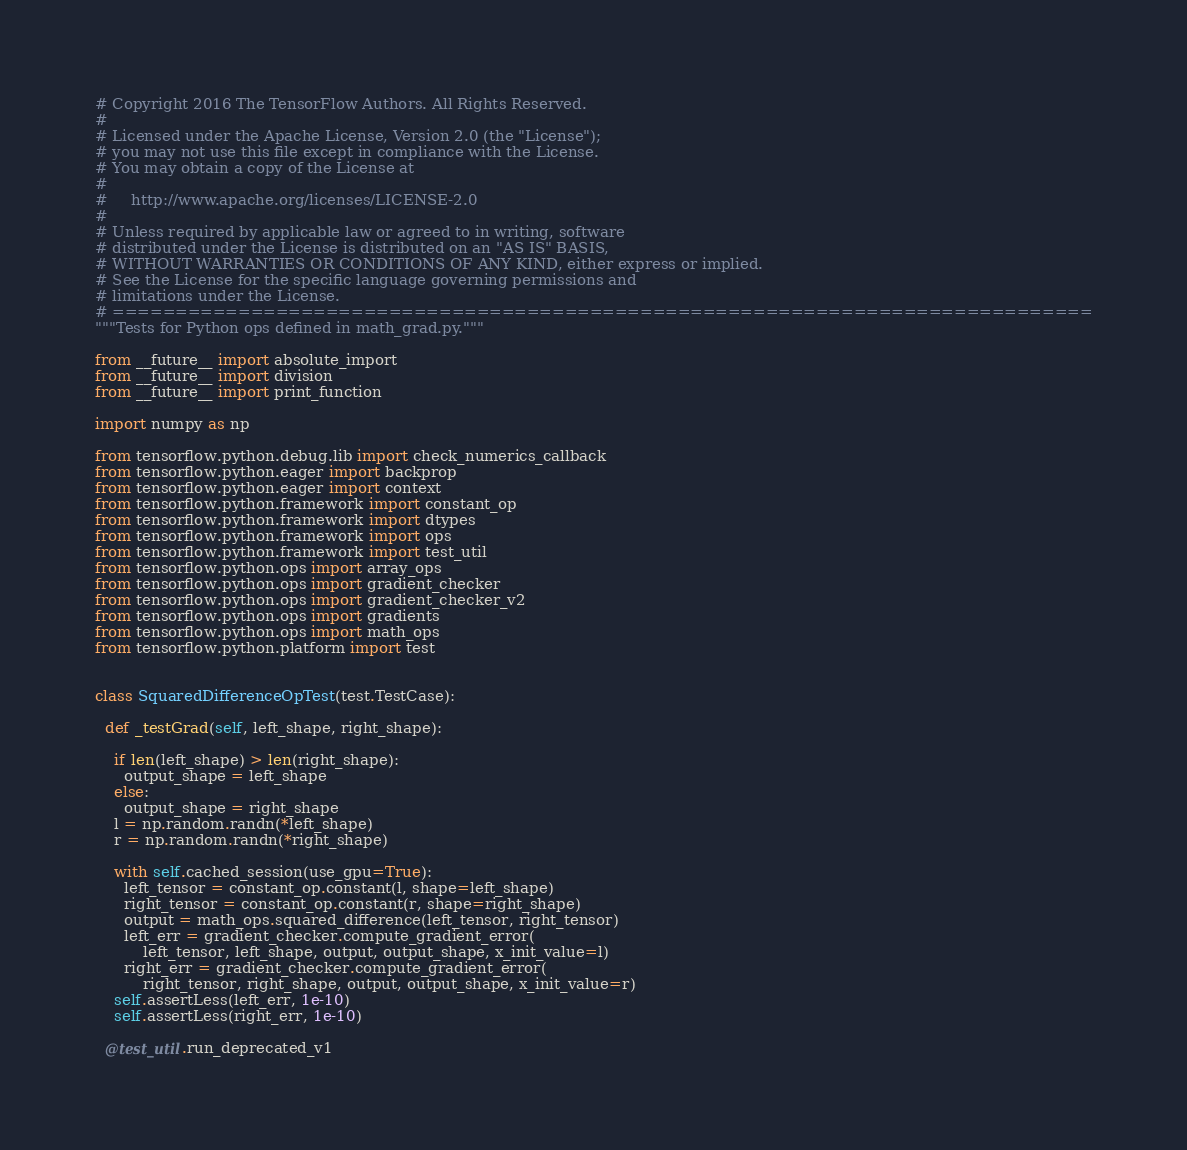Convert code to text. <code><loc_0><loc_0><loc_500><loc_500><_Python_># Copyright 2016 The TensorFlow Authors. All Rights Reserved.
#
# Licensed under the Apache License, Version 2.0 (the "License");
# you may not use this file except in compliance with the License.
# You may obtain a copy of the License at
#
#     http://www.apache.org/licenses/LICENSE-2.0
#
# Unless required by applicable law or agreed to in writing, software
# distributed under the License is distributed on an "AS IS" BASIS,
# WITHOUT WARRANTIES OR CONDITIONS OF ANY KIND, either express or implied.
# See the License for the specific language governing permissions and
# limitations under the License.
# ==============================================================================
"""Tests for Python ops defined in math_grad.py."""

from __future__ import absolute_import
from __future__ import division
from __future__ import print_function

import numpy as np

from tensorflow.python.debug.lib import check_numerics_callback
from tensorflow.python.eager import backprop
from tensorflow.python.eager import context
from tensorflow.python.framework import constant_op
from tensorflow.python.framework import dtypes
from tensorflow.python.framework import ops
from tensorflow.python.framework import test_util
from tensorflow.python.ops import array_ops
from tensorflow.python.ops import gradient_checker
from tensorflow.python.ops import gradient_checker_v2
from tensorflow.python.ops import gradients
from tensorflow.python.ops import math_ops
from tensorflow.python.platform import test


class SquaredDifferenceOpTest(test.TestCase):

  def _testGrad(self, left_shape, right_shape):

    if len(left_shape) > len(right_shape):
      output_shape = left_shape
    else:
      output_shape = right_shape
    l = np.random.randn(*left_shape)
    r = np.random.randn(*right_shape)

    with self.cached_session(use_gpu=True):
      left_tensor = constant_op.constant(l, shape=left_shape)
      right_tensor = constant_op.constant(r, shape=right_shape)
      output = math_ops.squared_difference(left_tensor, right_tensor)
      left_err = gradient_checker.compute_gradient_error(
          left_tensor, left_shape, output, output_shape, x_init_value=l)
      right_err = gradient_checker.compute_gradient_error(
          right_tensor, right_shape, output, output_shape, x_init_value=r)
    self.assertLess(left_err, 1e-10)
    self.assertLess(right_err, 1e-10)

  @test_util.run_deprecated_v1</code> 